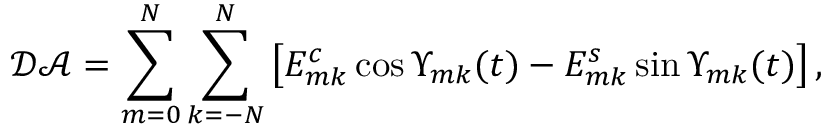<formula> <loc_0><loc_0><loc_500><loc_500>\mathcal { D A } = \sum _ { m = 0 } ^ { N } \sum _ { k = - N } ^ { N } \left [ E _ { m k } ^ { c } \cos \Upsilon _ { m k } ( t ) - E _ { m k } ^ { s } \sin \Upsilon _ { m k } ( t ) \right ] ,</formula> 